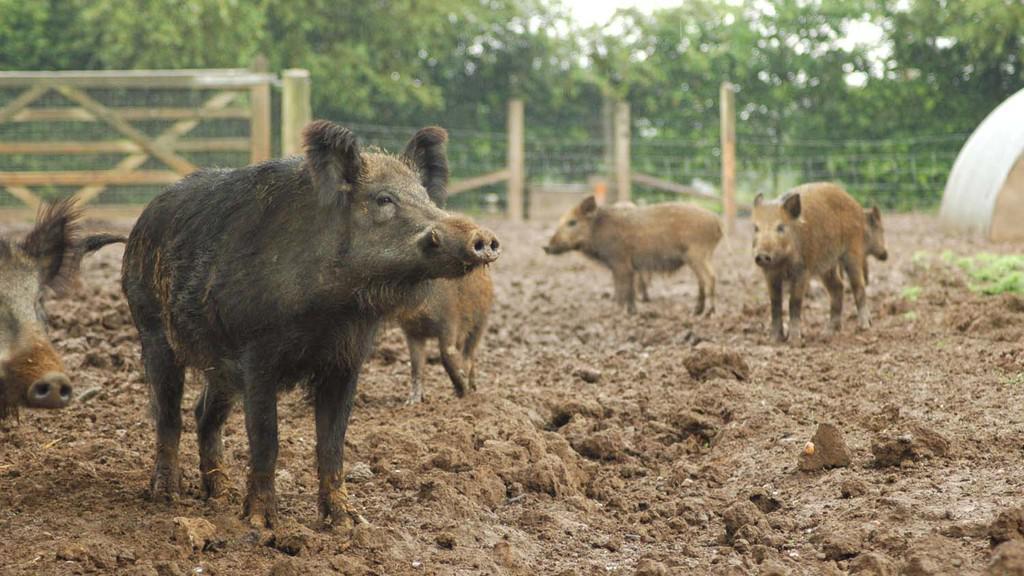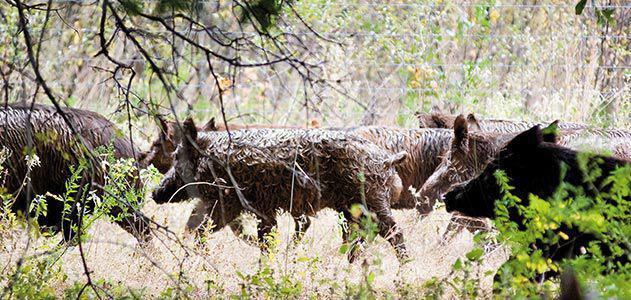The first image is the image on the left, the second image is the image on the right. For the images shown, is this caption "Each image contains a large rightward-facing boar and no left-facing boar, and in at least one image, the boar is dead and a hunter is posed behind it." true? Answer yes or no. No. The first image is the image on the left, the second image is the image on the right. Evaluate the accuracy of this statement regarding the images: "There is at least one hunter with their gun standing next to a dead boar.". Is it true? Answer yes or no. No. 